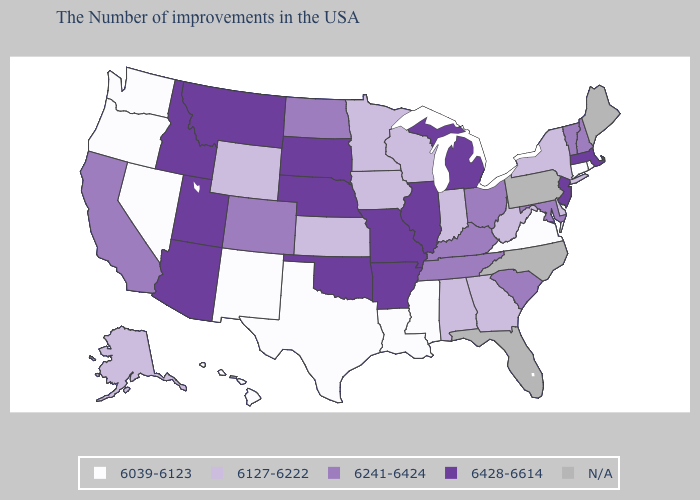What is the highest value in the USA?
Quick response, please. 6428-6614. What is the lowest value in states that border Louisiana?
Write a very short answer. 6039-6123. What is the value of North Dakota?
Give a very brief answer. 6241-6424. What is the value of Mississippi?
Write a very short answer. 6039-6123. Among the states that border North Dakota , does Montana have the highest value?
Write a very short answer. Yes. Name the states that have a value in the range 6428-6614?
Write a very short answer. Massachusetts, New Jersey, Michigan, Illinois, Missouri, Arkansas, Nebraska, Oklahoma, South Dakota, Utah, Montana, Arizona, Idaho. What is the highest value in the USA?
Short answer required. 6428-6614. What is the value of New Hampshire?
Be succinct. 6241-6424. Does Missouri have the lowest value in the MidWest?
Concise answer only. No. Which states have the lowest value in the USA?
Write a very short answer. Rhode Island, Connecticut, Virginia, Mississippi, Louisiana, Texas, New Mexico, Nevada, Washington, Oregon, Hawaii. Name the states that have a value in the range 6039-6123?
Quick response, please. Rhode Island, Connecticut, Virginia, Mississippi, Louisiana, Texas, New Mexico, Nevada, Washington, Oregon, Hawaii. Does the first symbol in the legend represent the smallest category?
Short answer required. Yes. What is the value of Maryland?
Answer briefly. 6241-6424. Does New Mexico have the highest value in the USA?
Keep it brief. No. What is the lowest value in the South?
Give a very brief answer. 6039-6123. 